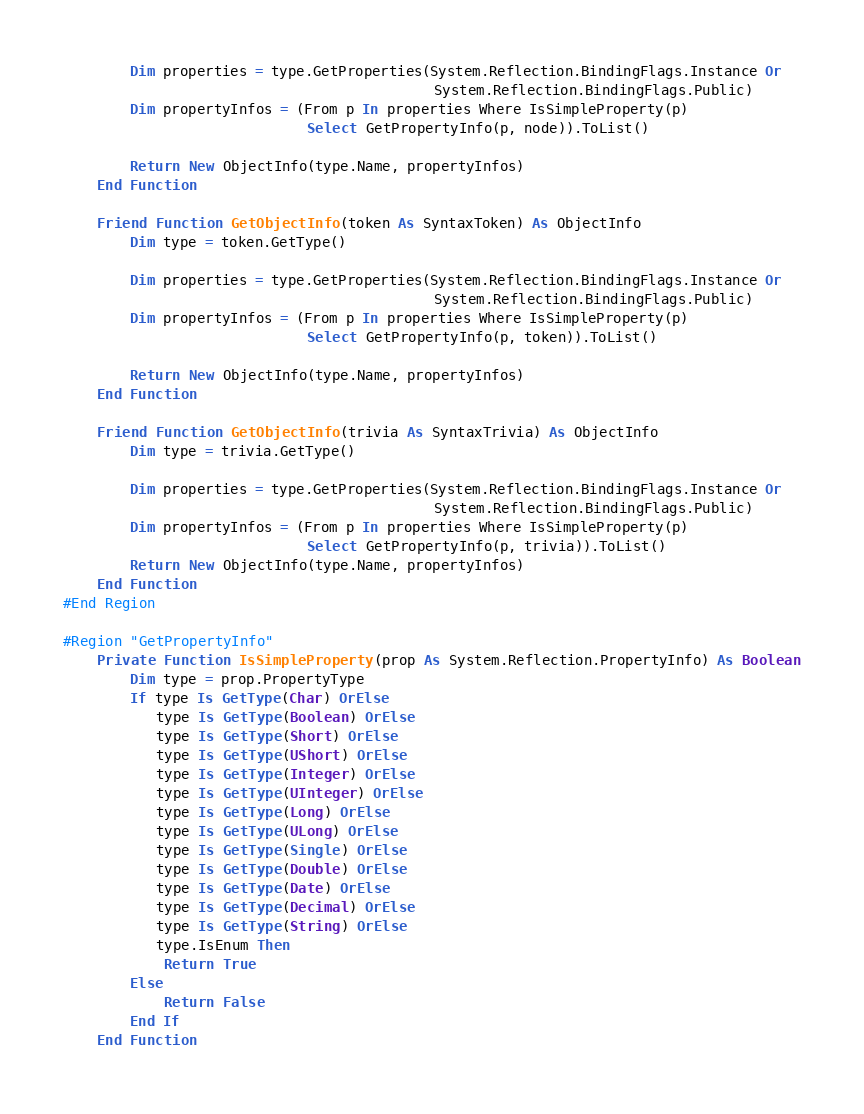Convert code to text. <code><loc_0><loc_0><loc_500><loc_500><_VisualBasic_>        Dim properties = type.GetProperties(System.Reflection.BindingFlags.Instance Or
                                            System.Reflection.BindingFlags.Public)
        Dim propertyInfos = (From p In properties Where IsSimpleProperty(p)
                             Select GetPropertyInfo(p, node)).ToList()

        Return New ObjectInfo(type.Name, propertyInfos)
    End Function

    Friend Function GetObjectInfo(token As SyntaxToken) As ObjectInfo
        Dim type = token.GetType()

        Dim properties = type.GetProperties(System.Reflection.BindingFlags.Instance Or
                                            System.Reflection.BindingFlags.Public)
        Dim propertyInfos = (From p In properties Where IsSimpleProperty(p)
                             Select GetPropertyInfo(p, token)).ToList()

        Return New ObjectInfo(type.Name, propertyInfos)
    End Function

    Friend Function GetObjectInfo(trivia As SyntaxTrivia) As ObjectInfo
        Dim type = trivia.GetType()

        Dim properties = type.GetProperties(System.Reflection.BindingFlags.Instance Or
                                            System.Reflection.BindingFlags.Public)
        Dim propertyInfos = (From p In properties Where IsSimpleProperty(p)
                             Select GetPropertyInfo(p, trivia)).ToList()
        Return New ObjectInfo(type.Name, propertyInfos)
    End Function
#End Region

#Region "GetPropertyInfo"
    Private Function IsSimpleProperty(prop As System.Reflection.PropertyInfo) As Boolean
        Dim type = prop.PropertyType
        If type Is GetType(Char) OrElse
           type Is GetType(Boolean) OrElse
           type Is GetType(Short) OrElse
           type Is GetType(UShort) OrElse
           type Is GetType(Integer) OrElse
           type Is GetType(UInteger) OrElse
           type Is GetType(Long) OrElse
           type Is GetType(ULong) OrElse
           type Is GetType(Single) OrElse
           type Is GetType(Double) OrElse
           type Is GetType(Date) OrElse
           type Is GetType(Decimal) OrElse
           type Is GetType(String) OrElse
           type.IsEnum Then
            Return True
        Else
            Return False
        End If
    End Function
</code> 